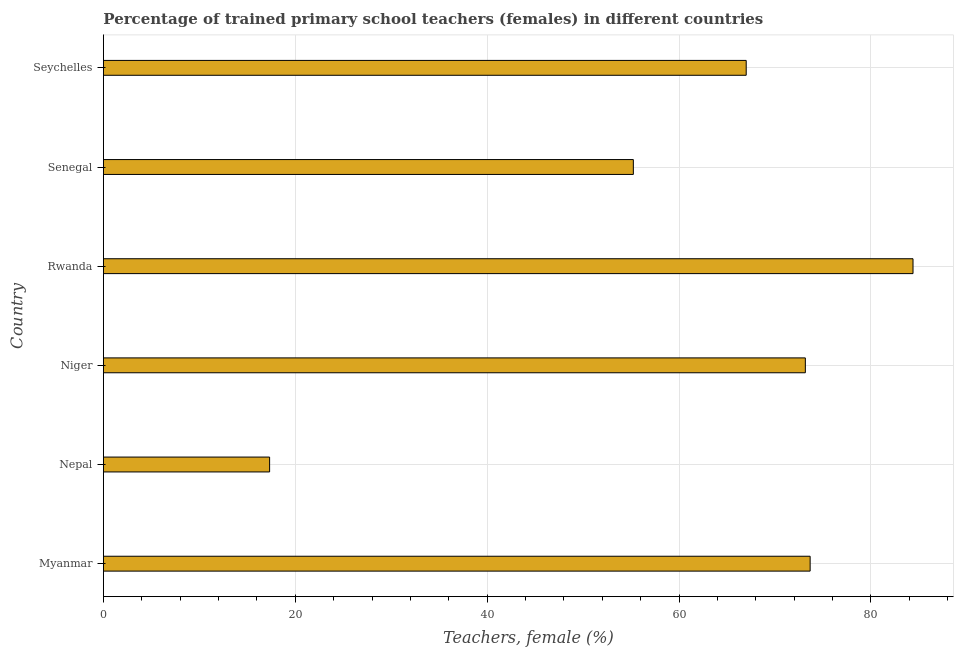Does the graph contain any zero values?
Your answer should be compact. No. What is the title of the graph?
Your answer should be compact. Percentage of trained primary school teachers (females) in different countries. What is the label or title of the X-axis?
Keep it short and to the point. Teachers, female (%). What is the percentage of trained female teachers in Rwanda?
Provide a succinct answer. 84.39. Across all countries, what is the maximum percentage of trained female teachers?
Keep it short and to the point. 84.39. Across all countries, what is the minimum percentage of trained female teachers?
Provide a succinct answer. 17.32. In which country was the percentage of trained female teachers maximum?
Provide a succinct answer. Rwanda. In which country was the percentage of trained female teachers minimum?
Your answer should be compact. Nepal. What is the sum of the percentage of trained female teachers?
Ensure brevity in your answer.  370.77. What is the difference between the percentage of trained female teachers in Myanmar and Nepal?
Your answer should be very brief. 56.34. What is the average percentage of trained female teachers per country?
Your response must be concise. 61.8. What is the median percentage of trained female teachers?
Provide a short and direct response. 70.08. In how many countries, is the percentage of trained female teachers greater than 40 %?
Provide a succinct answer. 5. What is the ratio of the percentage of trained female teachers in Nepal to that in Niger?
Your answer should be compact. 0.24. Is the percentage of trained female teachers in Myanmar less than that in Nepal?
Provide a short and direct response. No. Is the difference between the percentage of trained female teachers in Niger and Seychelles greater than the difference between any two countries?
Give a very brief answer. No. What is the difference between the highest and the second highest percentage of trained female teachers?
Your answer should be very brief. 10.72. What is the difference between the highest and the lowest percentage of trained female teachers?
Keep it short and to the point. 67.06. How many bars are there?
Offer a very short reply. 6. What is the difference between two consecutive major ticks on the X-axis?
Provide a short and direct response. 20. Are the values on the major ticks of X-axis written in scientific E-notation?
Provide a succinct answer. No. What is the Teachers, female (%) in Myanmar?
Provide a short and direct response. 73.66. What is the Teachers, female (%) in Nepal?
Keep it short and to the point. 17.32. What is the Teachers, female (%) in Niger?
Offer a terse response. 73.16. What is the Teachers, female (%) of Rwanda?
Provide a short and direct response. 84.39. What is the Teachers, female (%) of Senegal?
Provide a short and direct response. 55.24. What is the difference between the Teachers, female (%) in Myanmar and Nepal?
Offer a very short reply. 56.34. What is the difference between the Teachers, female (%) in Myanmar and Niger?
Make the answer very short. 0.5. What is the difference between the Teachers, female (%) in Myanmar and Rwanda?
Give a very brief answer. -10.72. What is the difference between the Teachers, female (%) in Myanmar and Senegal?
Ensure brevity in your answer.  18.43. What is the difference between the Teachers, female (%) in Myanmar and Seychelles?
Offer a very short reply. 6.66. What is the difference between the Teachers, female (%) in Nepal and Niger?
Provide a succinct answer. -55.84. What is the difference between the Teachers, female (%) in Nepal and Rwanda?
Offer a terse response. -67.06. What is the difference between the Teachers, female (%) in Nepal and Senegal?
Offer a terse response. -37.91. What is the difference between the Teachers, female (%) in Nepal and Seychelles?
Offer a very short reply. -49.68. What is the difference between the Teachers, female (%) in Niger and Rwanda?
Ensure brevity in your answer.  -11.22. What is the difference between the Teachers, female (%) in Niger and Senegal?
Ensure brevity in your answer.  17.93. What is the difference between the Teachers, female (%) in Niger and Seychelles?
Ensure brevity in your answer.  6.16. What is the difference between the Teachers, female (%) in Rwanda and Senegal?
Provide a succinct answer. 29.15. What is the difference between the Teachers, female (%) in Rwanda and Seychelles?
Give a very brief answer. 17.39. What is the difference between the Teachers, female (%) in Senegal and Seychelles?
Offer a terse response. -11.76. What is the ratio of the Teachers, female (%) in Myanmar to that in Nepal?
Your response must be concise. 4.25. What is the ratio of the Teachers, female (%) in Myanmar to that in Niger?
Ensure brevity in your answer.  1.01. What is the ratio of the Teachers, female (%) in Myanmar to that in Rwanda?
Provide a succinct answer. 0.87. What is the ratio of the Teachers, female (%) in Myanmar to that in Senegal?
Your answer should be compact. 1.33. What is the ratio of the Teachers, female (%) in Myanmar to that in Seychelles?
Your answer should be compact. 1.1. What is the ratio of the Teachers, female (%) in Nepal to that in Niger?
Your answer should be compact. 0.24. What is the ratio of the Teachers, female (%) in Nepal to that in Rwanda?
Your response must be concise. 0.2. What is the ratio of the Teachers, female (%) in Nepal to that in Senegal?
Offer a terse response. 0.31. What is the ratio of the Teachers, female (%) in Nepal to that in Seychelles?
Offer a very short reply. 0.26. What is the ratio of the Teachers, female (%) in Niger to that in Rwanda?
Offer a very short reply. 0.87. What is the ratio of the Teachers, female (%) in Niger to that in Senegal?
Make the answer very short. 1.32. What is the ratio of the Teachers, female (%) in Niger to that in Seychelles?
Your answer should be compact. 1.09. What is the ratio of the Teachers, female (%) in Rwanda to that in Senegal?
Ensure brevity in your answer.  1.53. What is the ratio of the Teachers, female (%) in Rwanda to that in Seychelles?
Offer a terse response. 1.26. What is the ratio of the Teachers, female (%) in Senegal to that in Seychelles?
Your answer should be compact. 0.82. 